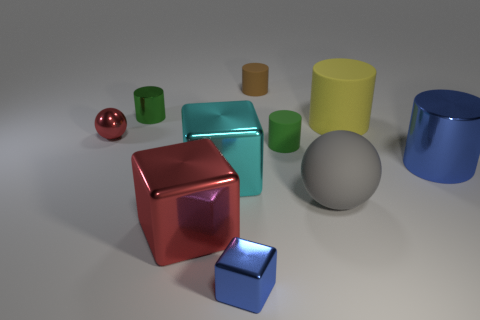What color is the tiny matte cylinder that is behind the green cylinder in front of the metallic cylinder on the left side of the large cyan thing? brown 